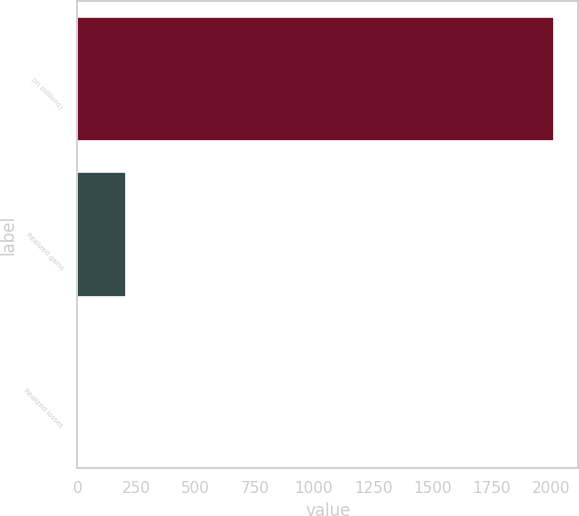<chart> <loc_0><loc_0><loc_500><loc_500><bar_chart><fcel>(in millions)<fcel>Realized gains<fcel>Realized losses<nl><fcel>2015<fcel>203.3<fcel>2<nl></chart> 